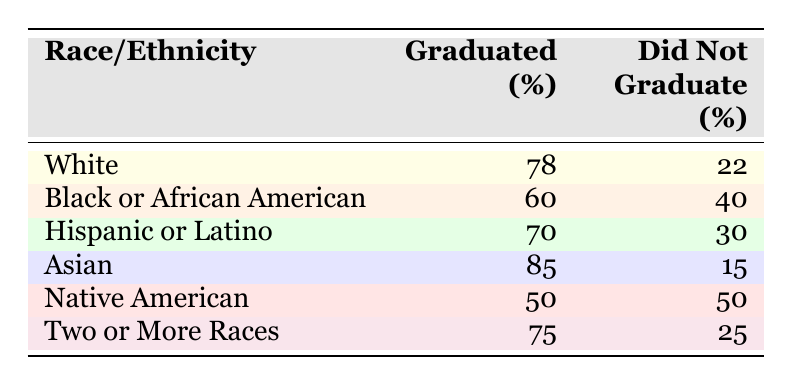What is the graduation rate for White students? The table shows that the graduation rate for White students is listed directly in the row under "Graduated (%)". It indicates that 78 percent of White students graduated.
Answer: 78% Which racial or ethnic group has the lowest graduation rate? By checking the "Graduated (%)" values in the table, the lowest percentage is found under "Native American", which is 50 percent.
Answer: Native American What is the difference in graduation rates between Asian and Black or African American students? The graduation rate for Asian students is 85 percent, and for Black or African American students, it is 60 percent. The difference is calculated as 85 - 60 = 25.
Answer: 25% If a student is from the Hispanic or Latino group, what is the likelihood (in percentage) that they did not graduate? The table provides the "Did Not Graduate (%)" value for Hispanic or Latino students, which is 30 percent. This indicates the likelihood of not graduating.
Answer: 30% Are more than 70 percent of Two or More Races students graduating? The graduation rate for students identifying as Two or More Races is given as 75 percent. Since 75 is greater than 70, the answer to this question is yes.
Answer: Yes What is the average graduation rate for all the groups listed? To find the average graduation rate, we sum all graduation rates (78 + 60 + 70 + 85 + 50 + 75) = 418, and then divide by the number of groups (6), which equals 418 / 6 = 69.67.
Answer: 69.67% How many percent of Black or African American students did not graduate? The table states that 40 percent of Black or African American students did not graduate, which can be found directly in the row for that group.
Answer: 40% Which two racial or ethnic groups have graduation rates that are closest to each other? Comparing the graduation rates, the closest values are for Hispanic or Latino (70%) and Two or More Races (75%). The difference between them is 5 percentage points which is the smallest among all the groups.
Answer: Hispanic or Latino and Two or More Races 